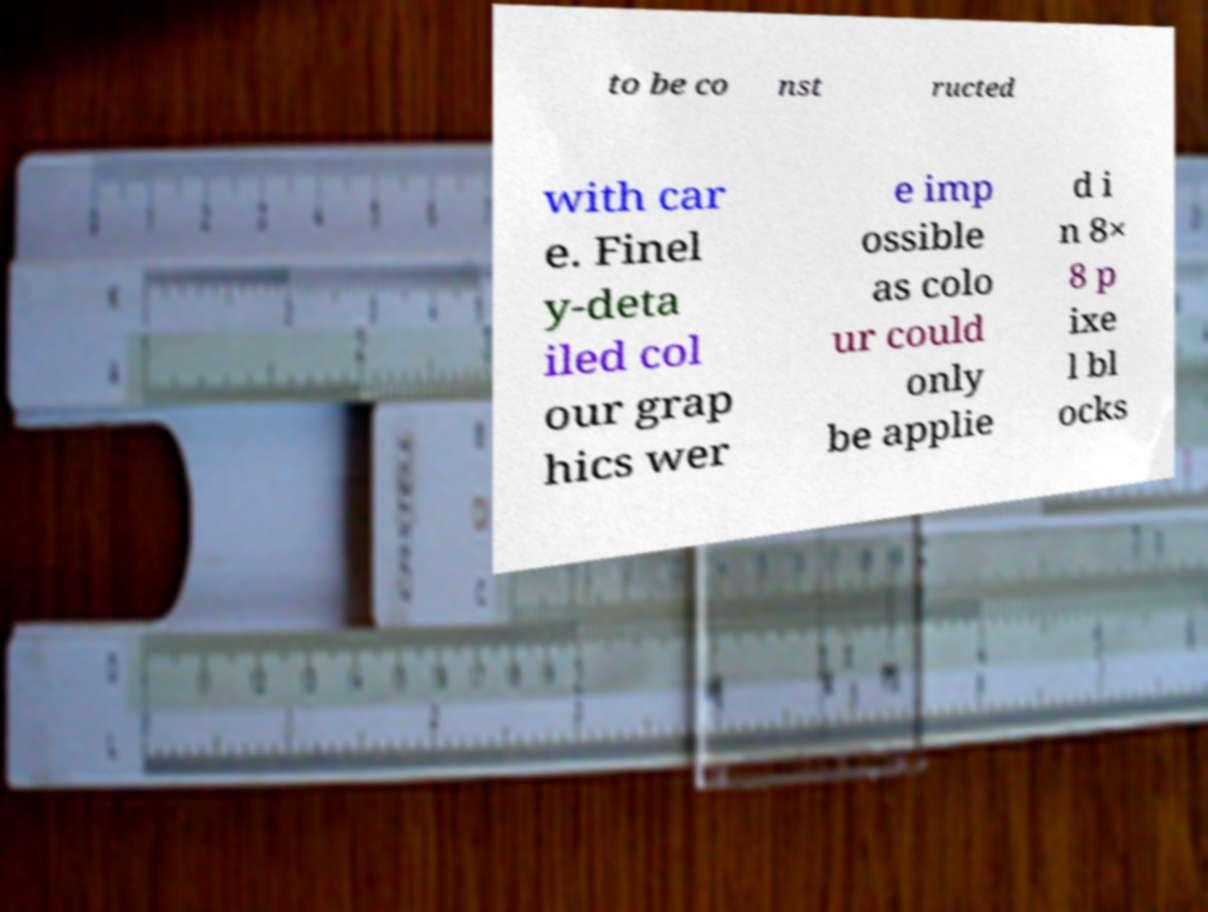Could you extract and type out the text from this image? to be co nst ructed with car e. Finel y-deta iled col our grap hics wer e imp ossible as colo ur could only be applie d i n 8× 8 p ixe l bl ocks 